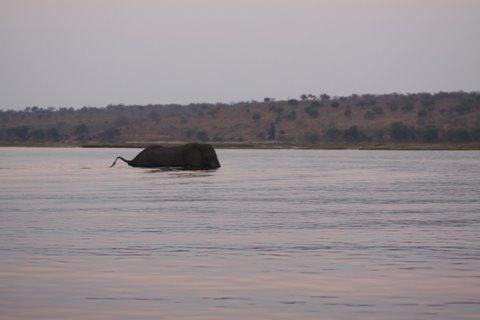Is there a boat?
Short answer required. No. Is there a house here?
Give a very brief answer. No. Is the water calm?
Quick response, please. Yes. What animal is in the water?
Concise answer only. Elephant. 